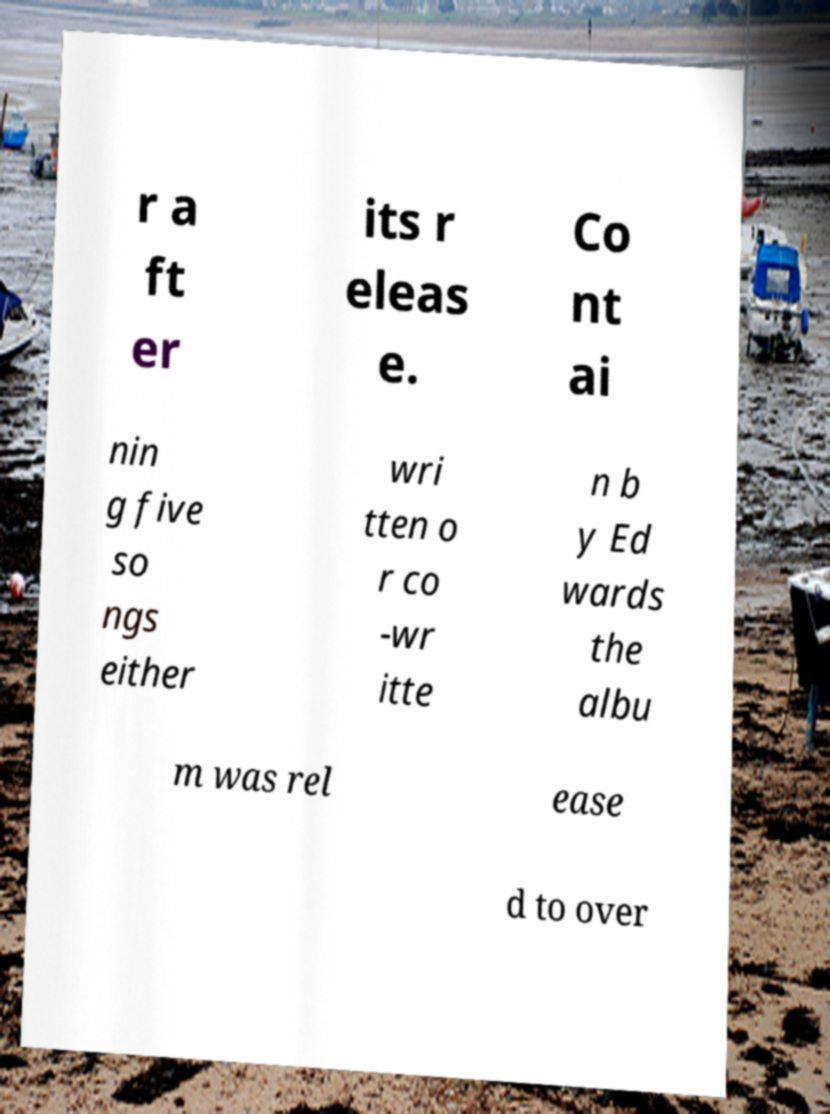Could you assist in decoding the text presented in this image and type it out clearly? r a ft er its r eleas e. Co nt ai nin g five so ngs either wri tten o r co -wr itte n b y Ed wards the albu m was rel ease d to over 